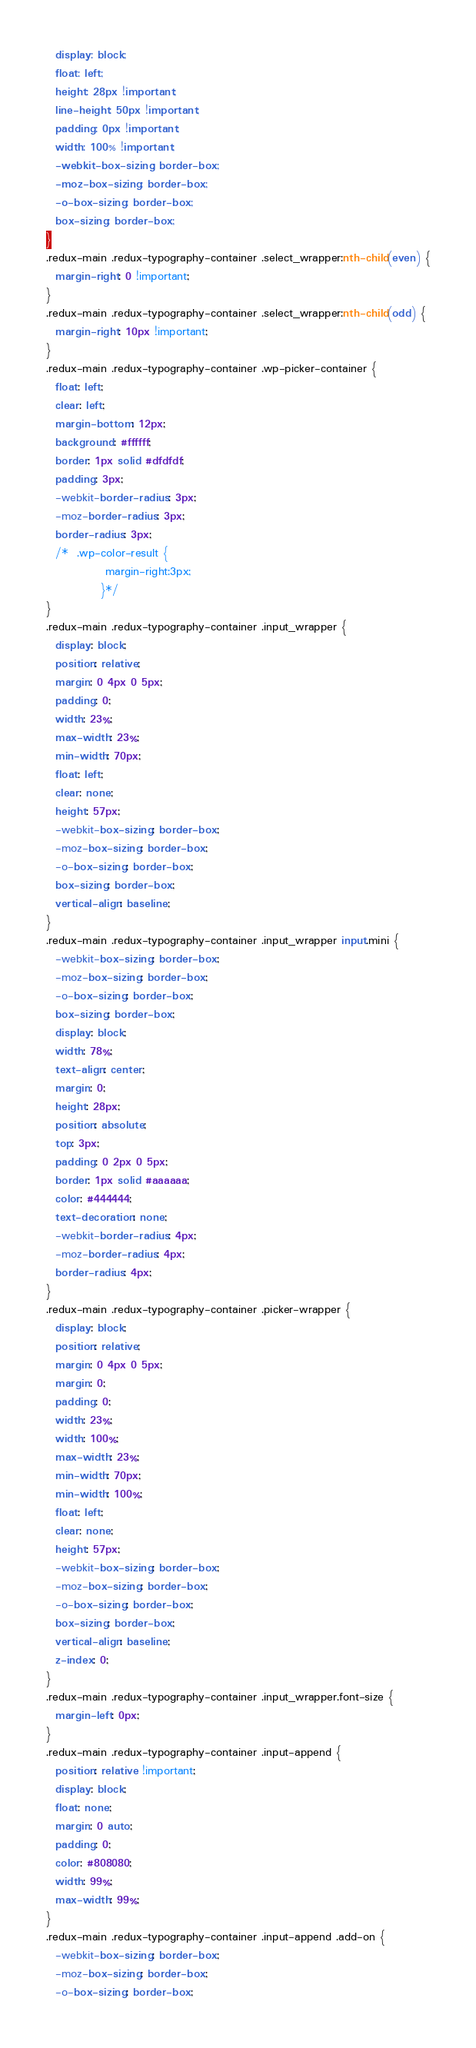Convert code to text. <code><loc_0><loc_0><loc_500><loc_500><_CSS_>  display: block;
  float: left;
  height: 28px !important;
  line-height: 50px !important;
  padding: 0px !important;
  width: 100% !important;
  -webkit-box-sizing: border-box;
  -moz-box-sizing: border-box;
  -o-box-sizing: border-box;
  box-sizing: border-box;
}
.redux-main .redux-typography-container .select_wrapper:nth-child(even) {
  margin-right: 0 !important;
}
.redux-main .redux-typography-container .select_wrapper:nth-child(odd) {
  margin-right: 10px !important;
}
.redux-main .redux-typography-container .wp-picker-container {
  float: left;
  clear: left;
  margin-bottom: 12px;
  background: #ffffff;
  border: 1px solid #dfdfdf;
  padding: 3px;
  -webkit-border-radius: 3px;
  -moz-border-radius: 3px;
  border-radius: 3px;
  /*  .wp-color-result {
             margin-right:3px;
            }*/
}
.redux-main .redux-typography-container .input_wrapper {
  display: block;
  position: relative;
  margin: 0 4px 0 5px;
  padding: 0;
  width: 23%;
  max-width: 23%;
  min-width: 70px;
  float: left;
  clear: none;
  height: 57px;
  -webkit-box-sizing: border-box;
  -moz-box-sizing: border-box;
  -o-box-sizing: border-box;
  box-sizing: border-box;
  vertical-align: baseline;
}
.redux-main .redux-typography-container .input_wrapper input.mini {
  -webkit-box-sizing: border-box;
  -moz-box-sizing: border-box;
  -o-box-sizing: border-box;
  box-sizing: border-box;
  display: block;
  width: 78%;
  text-align: center;
  margin: 0;
  height: 28px;
  position: absolute;
  top: 3px;
  padding: 0 2px 0 5px;
  border: 1px solid #aaaaaa;
  color: #444444;
  text-decoration: none;
  -webkit-border-radius: 4px;
  -moz-border-radius: 4px;
  border-radius: 4px;
}
.redux-main .redux-typography-container .picker-wrapper {
  display: block;
  position: relative;
  margin: 0 4px 0 5px;
  margin: 0;
  padding: 0;
  width: 23%;
  width: 100%;
  max-width: 23%;
  min-width: 70px;
  min-width: 100%;
  float: left;
  clear: none;
  height: 57px;
  -webkit-box-sizing: border-box;
  -moz-box-sizing: border-box;
  -o-box-sizing: border-box;
  box-sizing: border-box;
  vertical-align: baseline;
  z-index: 0;
}
.redux-main .redux-typography-container .input_wrapper.font-size {
  margin-left: 0px;
}
.redux-main .redux-typography-container .input-append {
  position: relative !important;
  display: block;
  float: none;
  margin: 0 auto;
  padding: 0;
  color: #808080;
  width: 99%;
  max-width: 99%;
}
.redux-main .redux-typography-container .input-append .add-on {
  -webkit-box-sizing: border-box;
  -moz-box-sizing: border-box;
  -o-box-sizing: border-box;</code> 